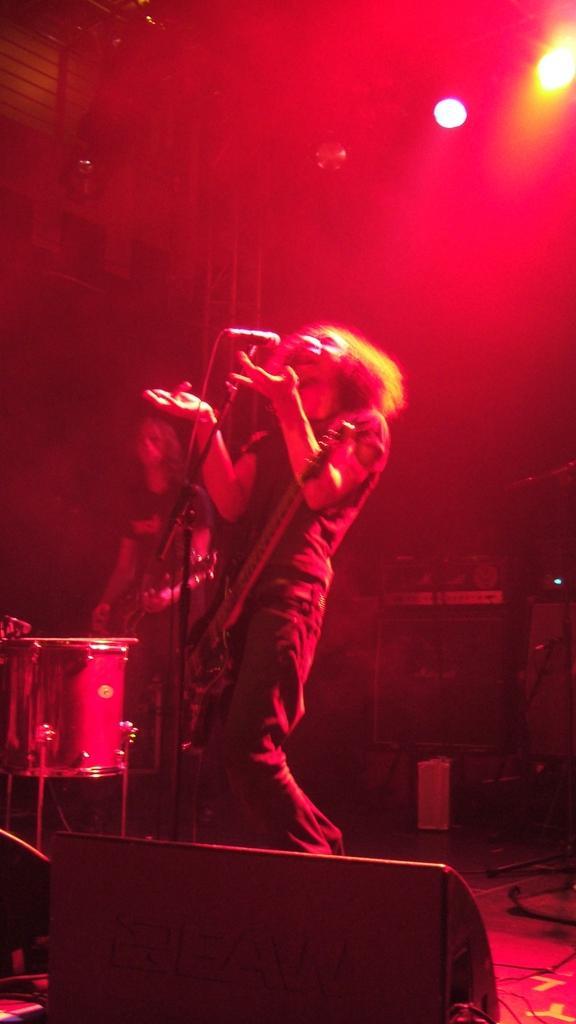Describe this image in one or two sentences. In the image in the center we can see two persons were standing and holding guitar. In front,of them,we can see one microphone and drum. In the bottom of the image,we can see some object. In the background there is a wall,roof,lights,musical instruments and few other objects. 